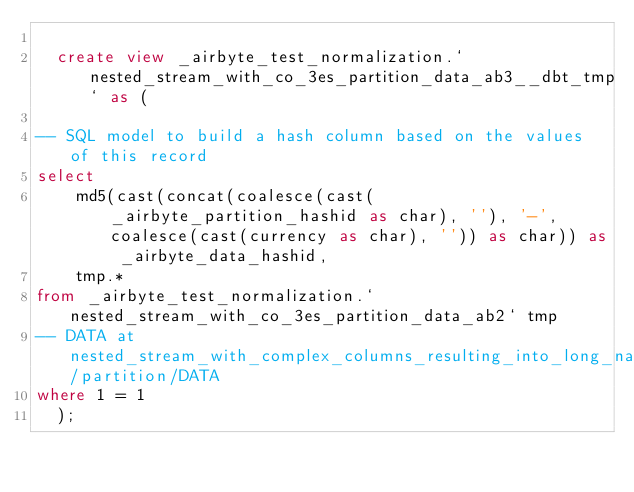Convert code to text. <code><loc_0><loc_0><loc_500><loc_500><_SQL_>
  create view _airbyte_test_normalization.`nested_stream_with_co_3es_partition_data_ab3__dbt_tmp` as (
    
-- SQL model to build a hash column based on the values of this record
select
    md5(cast(concat(coalesce(cast(_airbyte_partition_hashid as char), ''), '-', coalesce(cast(currency as char), '')) as char)) as _airbyte_data_hashid,
    tmp.*
from _airbyte_test_normalization.`nested_stream_with_co_3es_partition_data_ab2` tmp
-- DATA at nested_stream_with_complex_columns_resulting_into_long_names/partition/DATA
where 1 = 1
  );
</code> 